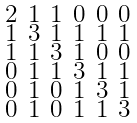Convert formula to latex. <formula><loc_0><loc_0><loc_500><loc_500>\begin{smallmatrix} 2 & 1 & 1 & 0 & 0 & 0 \\ 1 & 3 & 1 & 1 & 1 & 1 \\ 1 & 1 & 3 & 1 & 0 & 0 \\ 0 & 1 & 1 & 3 & 1 & 1 \\ 0 & 1 & 0 & 1 & 3 & 1 \\ 0 & 1 & 0 & 1 & 1 & 3 \end{smallmatrix}</formula> 